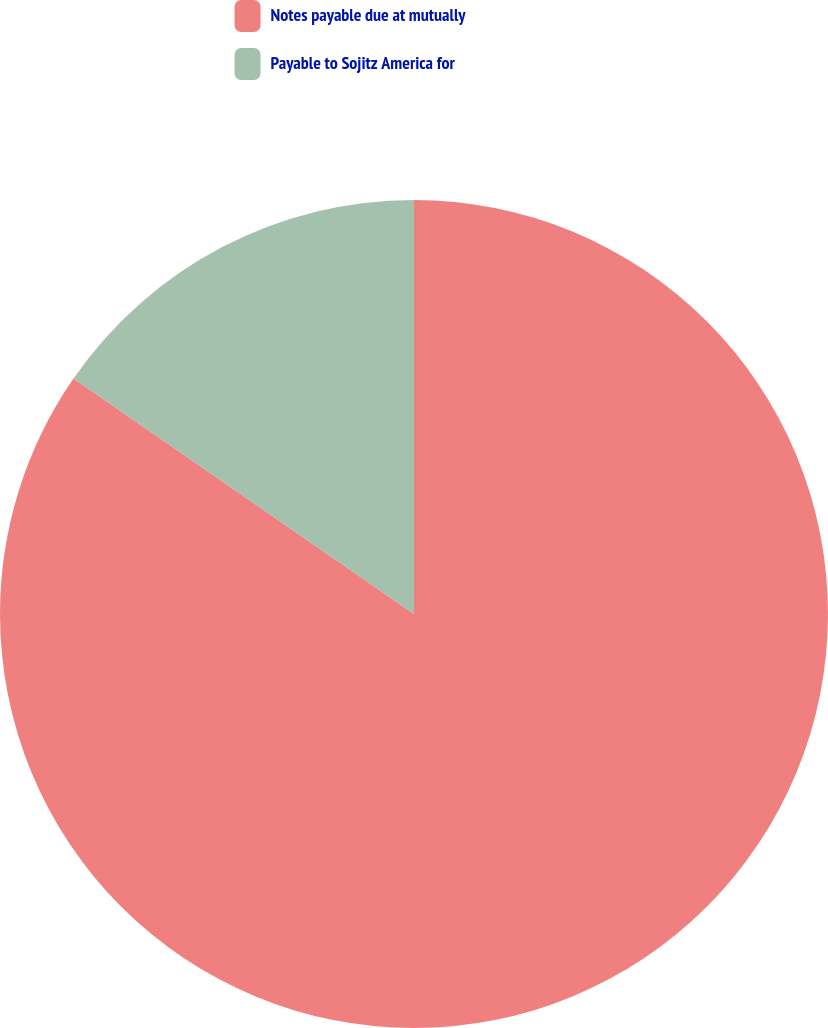<chart> <loc_0><loc_0><loc_500><loc_500><pie_chart><fcel>Notes payable due at mutually<fcel>Payable to Sojitz America for<nl><fcel>84.63%<fcel>15.37%<nl></chart> 